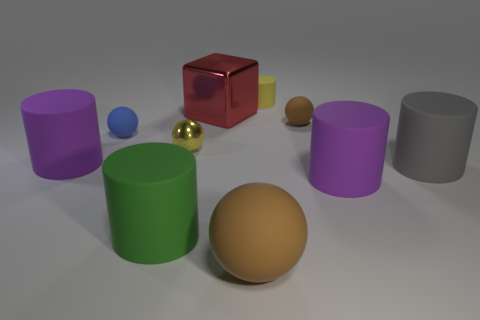Subtract all tiny blue spheres. How many spheres are left? 3 Subtract all purple cylinders. How many cylinders are left? 3 Subtract all blue balls. How many purple cylinders are left? 2 Subtract 4 balls. How many balls are left? 0 Subtract all large green objects. Subtract all red metallic cubes. How many objects are left? 8 Add 9 tiny yellow matte things. How many tiny yellow matte things are left? 10 Add 8 tiny yellow cylinders. How many tiny yellow cylinders exist? 9 Subtract 1 purple cylinders. How many objects are left? 9 Subtract all cubes. How many objects are left? 9 Subtract all yellow cylinders. Subtract all blue blocks. How many cylinders are left? 4 